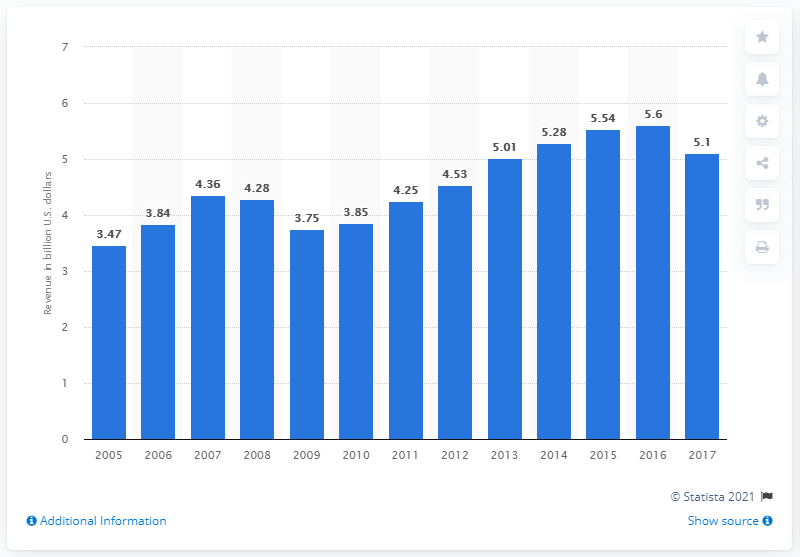Give some essential details in this illustration. In 2017, Wyndham Worldwide Corporation generated approximately 5.1 billion US dollars in revenue. 